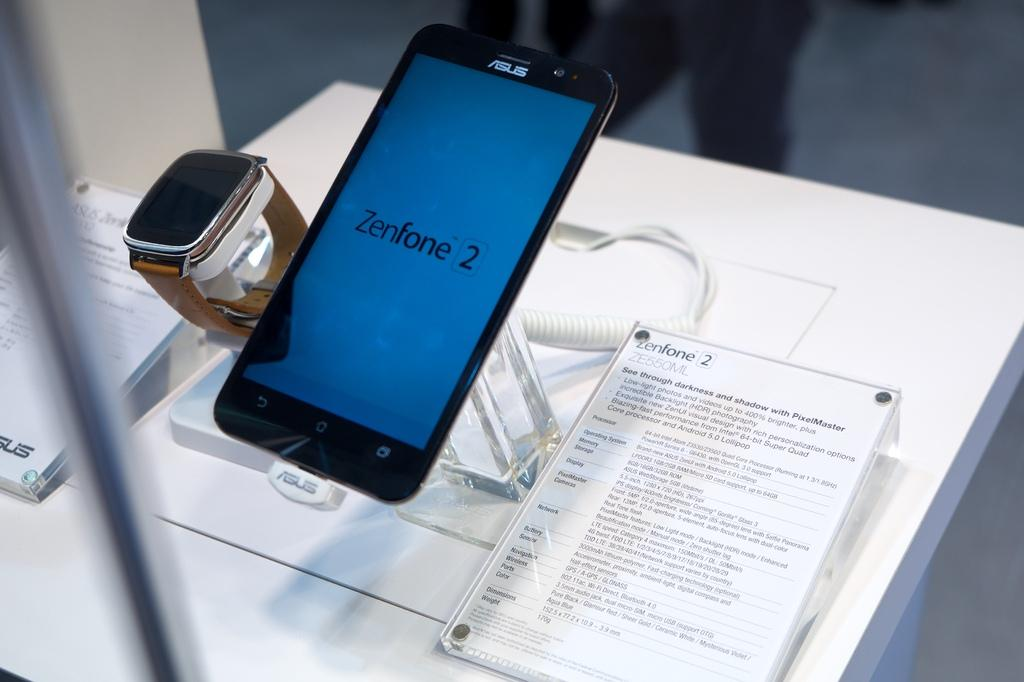<image>
Summarize the visual content of the image. Sign for a phone which says "Zenfone 2" on it. 